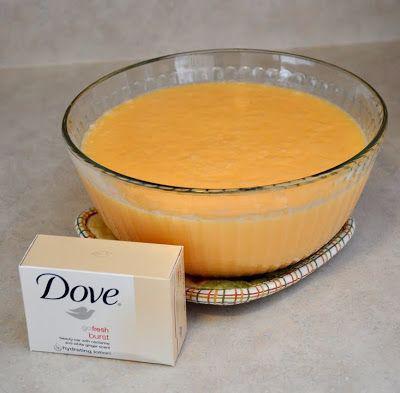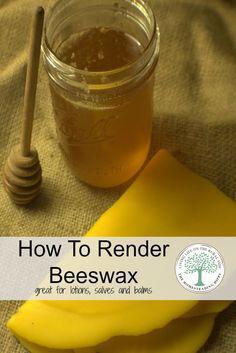The first image is the image on the left, the second image is the image on the right. Considering the images on both sides, is "An image includes an item of silverware and a clear unlidded glass jar containing a creamy pale yellow substance." valid? Answer yes or no. No. 